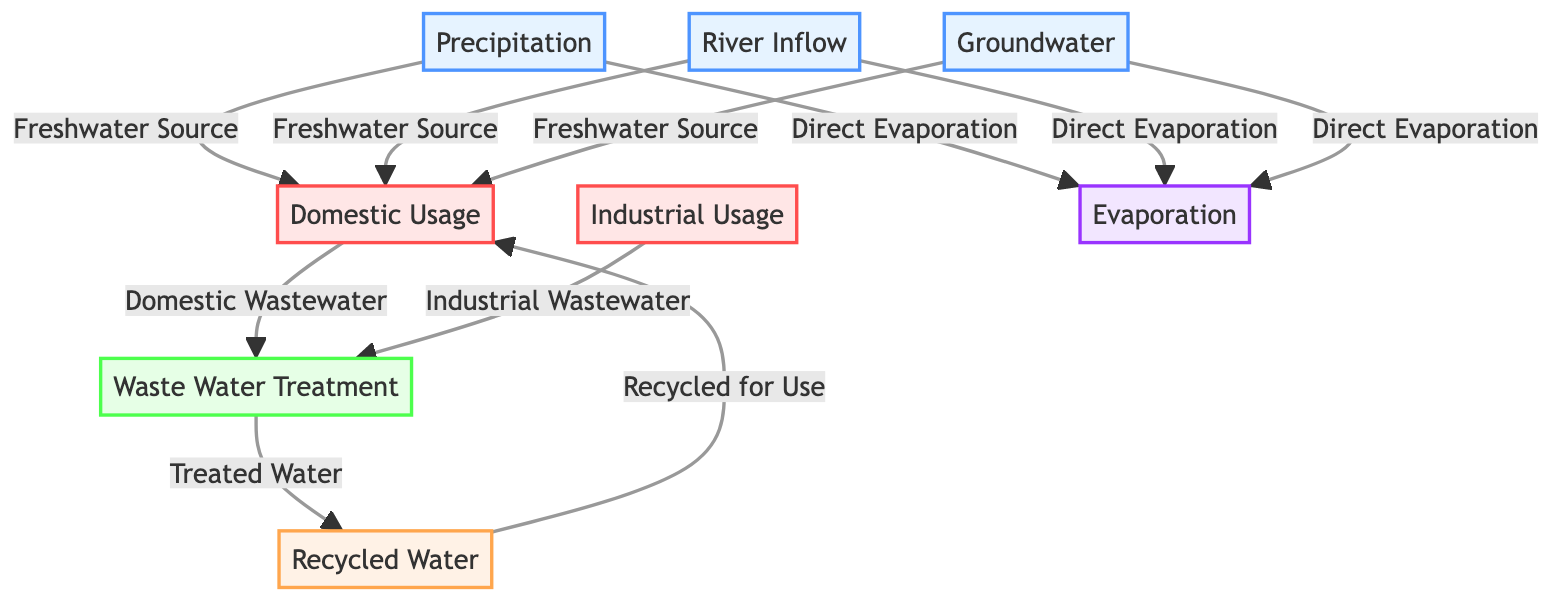What are the three main sources of water in the diagram? The diagram lists "Precipitation," "River Inflow," and "Groundwater" as the three main sources of water, each represented as nodes connected to the Domestic Usage node.
Answer: Precipitation, River Inflow, Groundwater How many types of usage are shown in the diagram? The diagram has two distinct types of usage: "Domestic Usage" and "Industrial Usage," which are labeled and clearly separated within the usage category.
Answer: 2 Which process receives both domestic and industrial wastewater? "Waste Water Treatment" is the process that receives flows from both "Domestic Usage" and "Industrial Usage," as indicated by arrows connecting these nodes to it.
Answer: Waste Water Treatment What is the final output of the treated water? The final output of the treated water is "Recycled Water," as indicated by the directional flow from "Waste Water Treatment" to "Recycled Water" in the diagram.
Answer: Recycled Water How does evaporation from precipitation occur according to the diagram? The diagram shows that evaporation can occur directly from both "Precipitation" and "River Inflow," as there are arrows leading from these sources to the "Evaporation" node, indicating that water can change to vapor from these sources.
Answer: Direct Evaporation What happens to recycled water after treatment? After treatment, the recycled water is used again for "Domestic Usage," which is depicted by an arrow flowing from "Recycled Water" back to "Domestic Usage," establishing a circular pathway.
Answer: Recycled for Use Which source has the most direct flow path to the Domestic Usage node? The "Precipitation" source has the most direct flow path to "Domestic Usage," as it directly connects with an arrow indicating the flow of freshwater towards domestic use.
Answer: Precipitation How many nodes show processes related to treatment? There are two nodes that show processes related to treatment: "Waste Water Treatment" and "Recycled Water," highlighting the various stages in the treatment cycle.
Answer: 2 